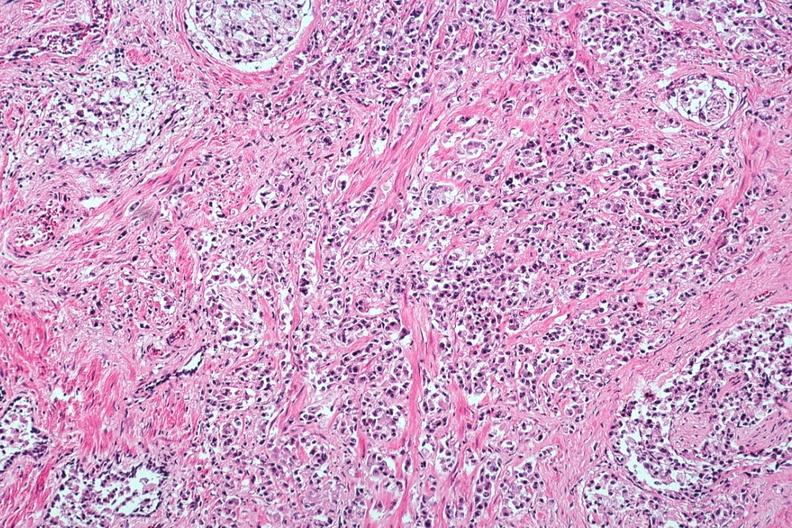what does this image show?
Answer the question using a single word or phrase. Typical infiltrating carcinoma with perineural invasion 